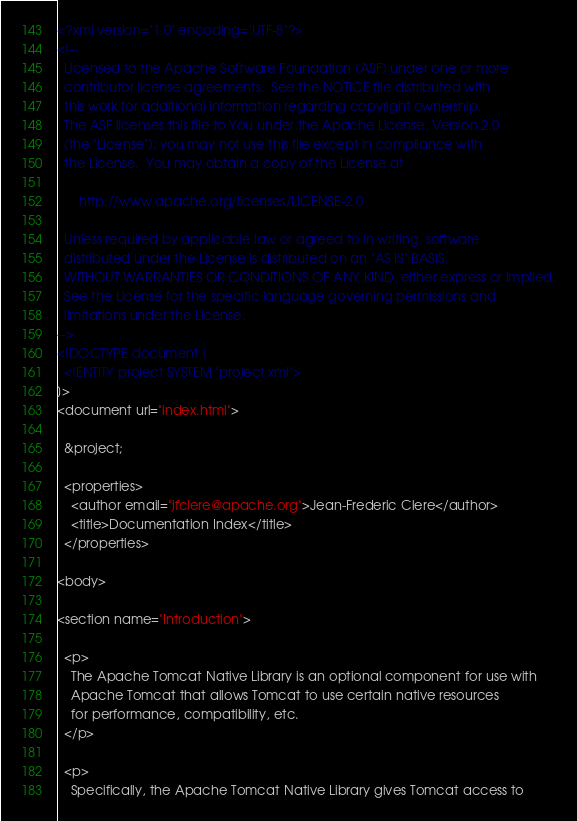Convert code to text. <code><loc_0><loc_0><loc_500><loc_500><_XML_><?xml version="1.0" encoding="UTF-8"?>
<!--
  Licensed to the Apache Software Foundation (ASF) under one or more
  contributor license agreements.  See the NOTICE file distributed with
  this work for additional information regarding copyright ownership.
  The ASF licenses this file to You under the Apache License, Version 2.0
  (the "License"); you may not use this file except in compliance with
  the License.  You may obtain a copy of the License at

      http://www.apache.org/licenses/LICENSE-2.0

  Unless required by applicable law or agreed to in writing, software
  distributed under the License is distributed on an "AS IS" BASIS,
  WITHOUT WARRANTIES OR CONDITIONS OF ANY KIND, either express or implied.
  See the License for the specific language governing permissions and
  limitations under the License.
-->
<!DOCTYPE document [
  <!ENTITY project SYSTEM "project.xml">
]>
<document url="index.html">

  &project;

  <properties>
    <author email="jfclere@apache.org">Jean-Frederic Clere</author>
    <title>Documentation Index</title>
  </properties>

<body>

<section name="Introduction">

  <p>
    The Apache Tomcat Native Library is an optional component for use with
    Apache Tomcat that allows Tomcat to use certain native resources
    for performance, compatibility, etc.
  </p>

  <p>
    Specifically, the Apache Tomcat Native Library gives Tomcat access to</code> 